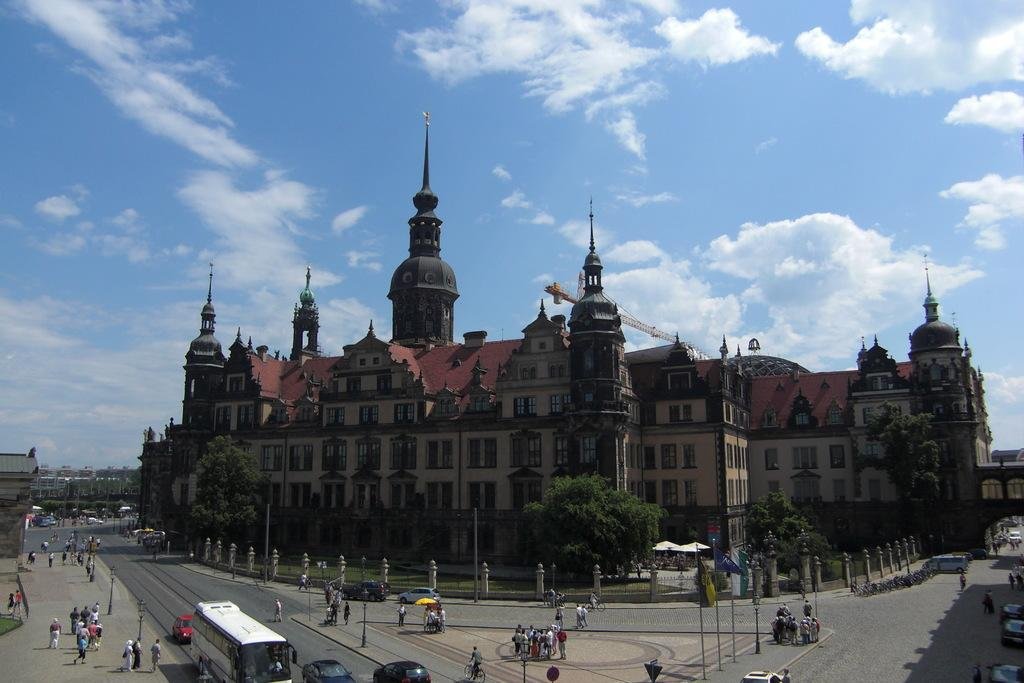What is the condition of the sky in the image? The sky is cloudy in the image. What type of structures can be seen in the image? There are buildings in the image. What feature do the buildings have? The buildings have windows. What is located in front of the buildings? There are trees, people, flags, and vehicles in front of the buildings. Can you tell me how many bananas are hanging from the trees in the image? There are no bananas present in the image; the trees are not fruit-bearing trees. What type of writing instrument is being used by the people in the image? There is no indication of any writing instruments being used by the people in the image. 